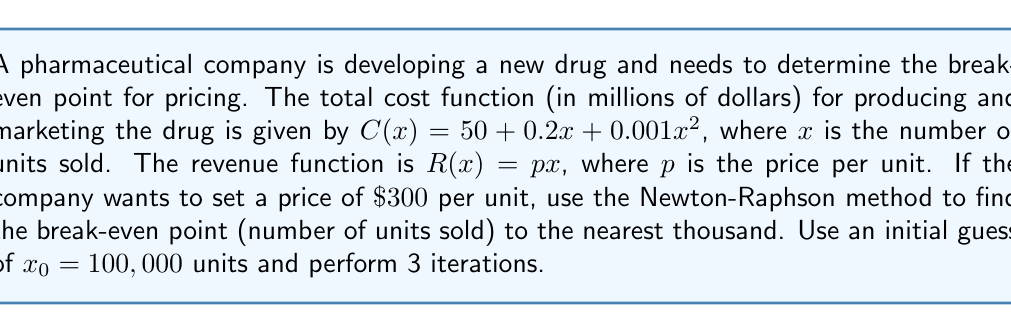Could you help me with this problem? To find the break-even point, we need to solve the equation $R(x) = C(x)$:

1) Set up the equation:
   $px = 50 + 0.2x + 0.001x^2$
   $300x = 50 + 0.2x + 0.001x^2$

2) Rearrange to get $f(x) = 0$:
   $f(x) = 0.001x^2 - 299.8x + 50 = 0$

3) The Newton-Raphson formula is:
   $x_{n+1} = x_n - \frac{f(x_n)}{f'(x_n)}$

4) Calculate $f'(x)$:
   $f'(x) = 0.002x - 299.8$

5) Perform iterations:

   Iteration 1:
   $f(100000) = 0.001(100000)^2 - 299.8(100000) + 50 = -19980000$
   $f'(100000) = 0.002(100000) - 299.8 = -99.8$
   $x_1 = 100000 - \frac{-19980000}{-99.8} \approx 300200.4$

   Iteration 2:
   $f(300200.4) = 0.001(300200.4)^2 - 299.8(300200.4) + 50 \approx 60.16$
   $f'(300200.4) = 0.002(300200.4) - 299.8 \approx 300.6$
   $x_2 = 300200.4 - \frac{60.16}{300.6} \approx 300000.2$

   Iteration 3:
   $f(300000.2) = 0.001(300000.2)^2 - 299.8(300000.2) + 50 \approx 0.06$
   $f'(300000.2) = 0.002(300000.2) - 299.8 \approx 300.2$
   $x_3 = 300000.2 - \frac{0.06}{300.2} \approx 300000.0$

6) Rounding to the nearest thousand:
   The break-even point is approximately 300,000 units.
Answer: 300,000 units 